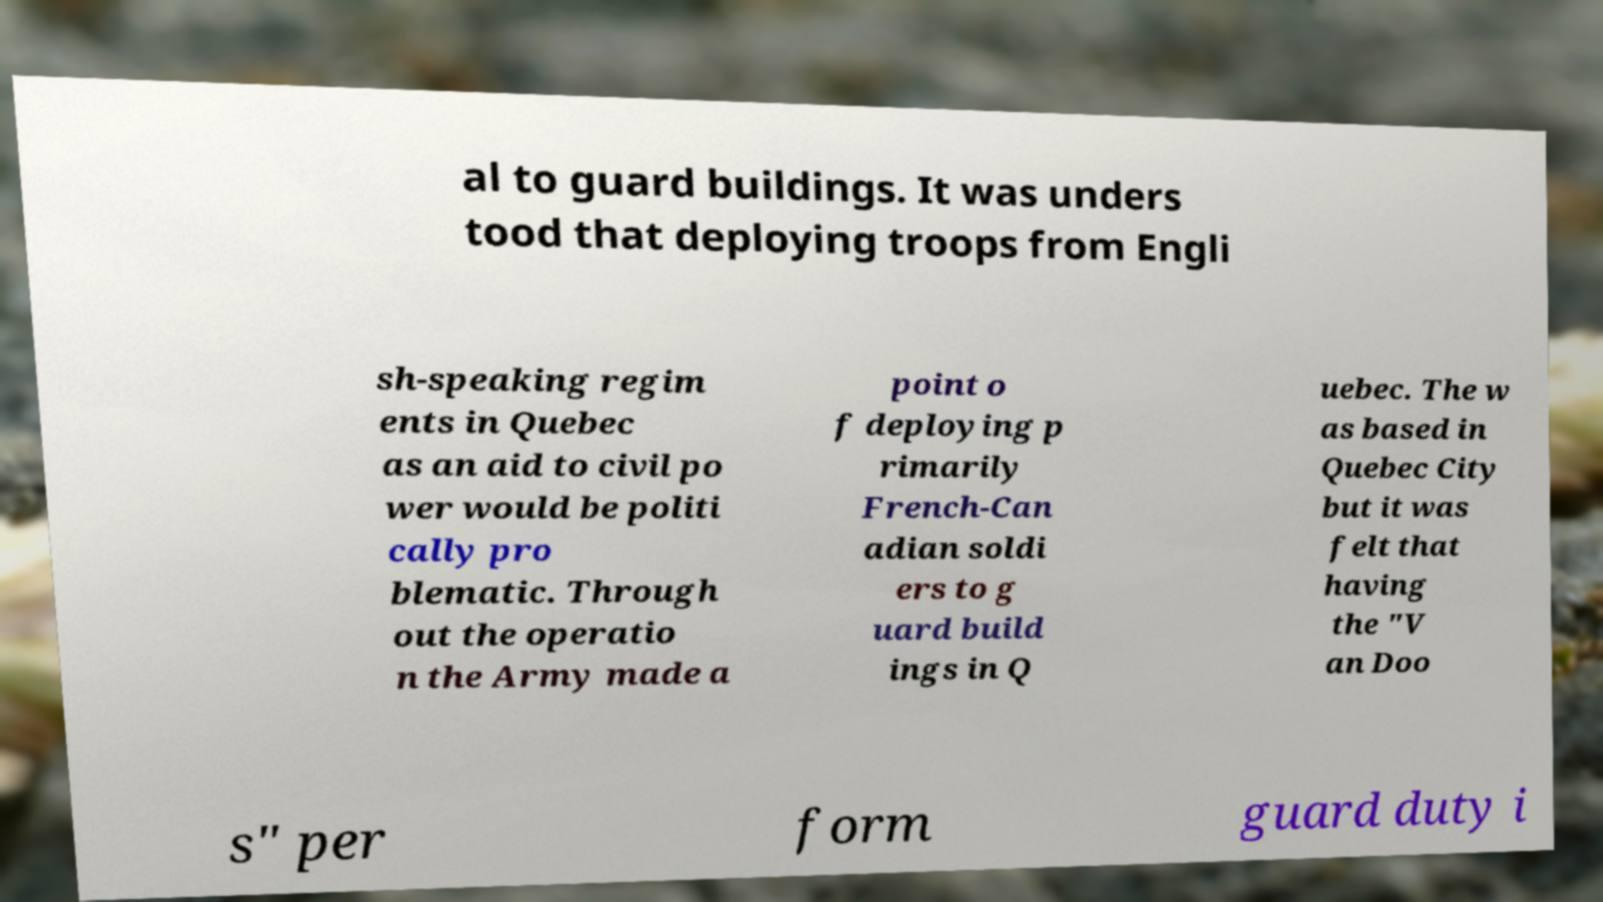Please identify and transcribe the text found in this image. al to guard buildings. It was unders tood that deploying troops from Engli sh-speaking regim ents in Quebec as an aid to civil po wer would be politi cally pro blematic. Through out the operatio n the Army made a point o f deploying p rimarily French-Can adian soldi ers to g uard build ings in Q uebec. The w as based in Quebec City but it was felt that having the "V an Doo s" per form guard duty i 